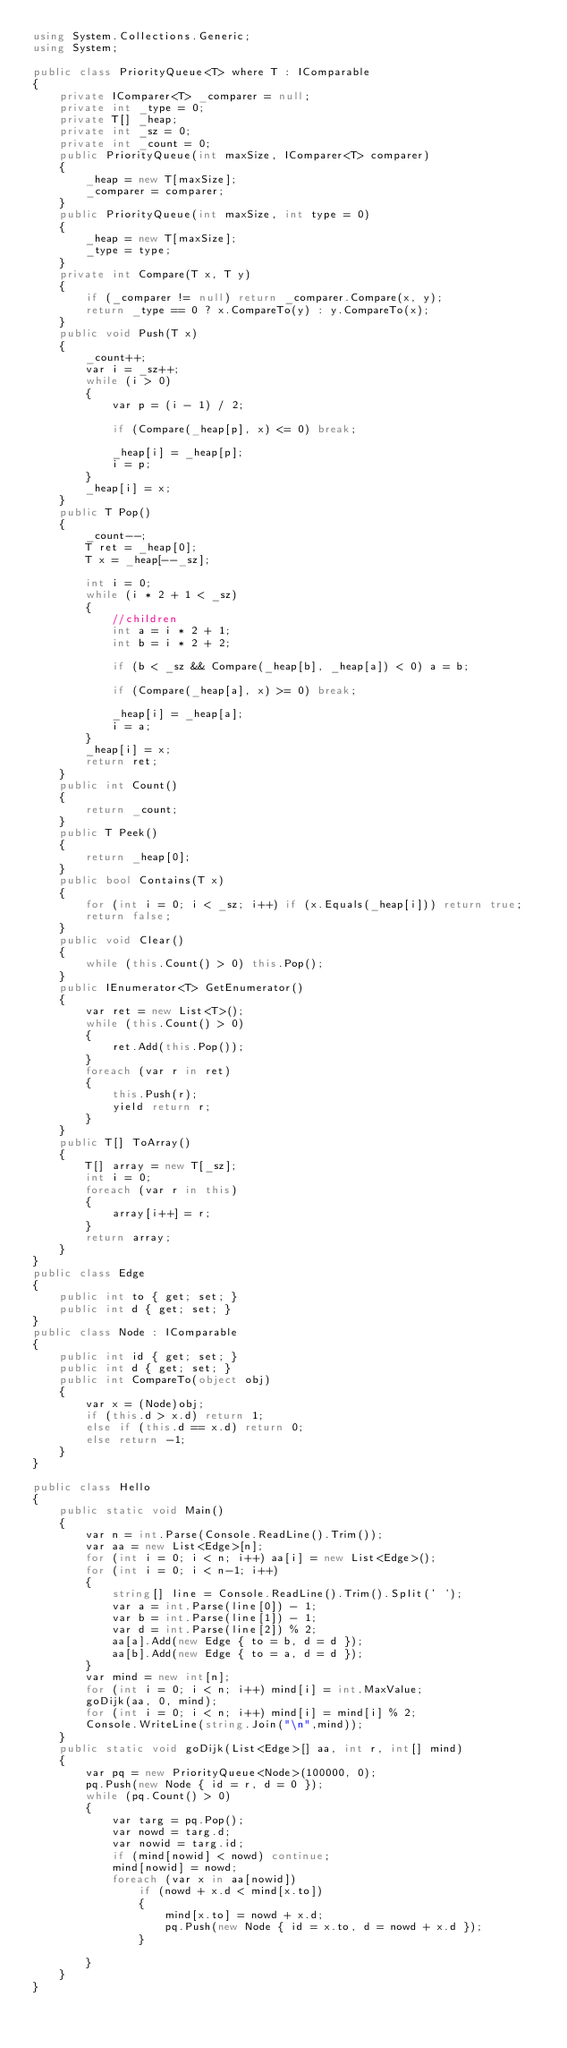Convert code to text. <code><loc_0><loc_0><loc_500><loc_500><_C#_>using System.Collections.Generic;
using System;

public class PriorityQueue<T> where T : IComparable
{
	private IComparer<T> _comparer = null;
	private int _type = 0;
	private T[] _heap;
	private int _sz = 0;
	private int _count = 0;
	public PriorityQueue(int maxSize, IComparer<T> comparer)
	{
		_heap = new T[maxSize];
		_comparer = comparer;
	}
	public PriorityQueue(int maxSize, int type = 0)
	{
		_heap = new T[maxSize];
		_type = type;
	}
	private int Compare(T x, T y)
	{
		if (_comparer != null) return _comparer.Compare(x, y);
		return _type == 0 ? x.CompareTo(y) : y.CompareTo(x);
	}
	public void Push(T x)
	{
		_count++;
		var i = _sz++;
		while (i > 0)
		{
			var p = (i - 1) / 2;

			if (Compare(_heap[p], x) <= 0) break;

			_heap[i] = _heap[p];
			i = p;
		}
		_heap[i] = x;
	}
	public T Pop()
	{
		_count--;
		T ret = _heap[0];
		T x = _heap[--_sz];

		int i = 0;
		while (i * 2 + 1 < _sz)
		{
			//children
			int a = i * 2 + 1;
			int b = i * 2 + 2;

			if (b < _sz && Compare(_heap[b], _heap[a]) < 0) a = b;

			if (Compare(_heap[a], x) >= 0) break;

			_heap[i] = _heap[a];
			i = a;
		}
		_heap[i] = x;
		return ret;
	}
	public int Count()
	{
		return _count;
	}
	public T Peek()
	{
		return _heap[0];
	}
	public bool Contains(T x)
	{
		for (int i = 0; i < _sz; i++) if (x.Equals(_heap[i])) return true;
		return false;
	}
	public void Clear()
	{
		while (this.Count() > 0) this.Pop();
	}
	public IEnumerator<T> GetEnumerator()
	{
		var ret = new List<T>();
		while (this.Count() > 0)
		{
			ret.Add(this.Pop());
		}
		foreach (var r in ret)
		{
			this.Push(r);
			yield return r;
		}
	}
	public T[] ToArray()
	{
		T[] array = new T[_sz];
		int i = 0;
		foreach (var r in this)
		{
			array[i++] = r;
		}
		return array;
	}
}
public class Edge
{
	public int to { get; set; }
	public int d { get; set; }
}
public class Node : IComparable
{
	public int id { get; set; }
	public int d { get; set; }
	public int CompareTo(object obj)
	{
		var x = (Node)obj;
		if (this.d > x.d) return 1;
		else if (this.d == x.d) return 0;
		else return -1;
	}
}

public class Hello
{
	public static void Main()
	{
		var n = int.Parse(Console.ReadLine().Trim());
		var aa = new List<Edge>[n];
		for (int i = 0; i < n; i++) aa[i] = new List<Edge>();
		for (int i = 0; i < n-1; i++)
		{
			string[] line = Console.ReadLine().Trim().Split(' ');
			var a = int.Parse(line[0]) - 1;
			var b = int.Parse(line[1]) - 1;
			var d = int.Parse(line[2]) % 2;
			aa[a].Add(new Edge { to = b, d = d });
			aa[b].Add(new Edge { to = a, d = d });
		}
		var mind = new int[n];
		for (int i = 0; i < n; i++) mind[i] = int.MaxValue;
		goDijk(aa, 0, mind);
		for (int i = 0; i < n; i++) mind[i] = mind[i] % 2;
		Console.WriteLine(string.Join("\n",mind));
	}
	public static void goDijk(List<Edge>[] aa, int r, int[] mind)
	{
		var pq = new PriorityQueue<Node>(100000, 0);
		pq.Push(new Node { id = r, d = 0 });
		while (pq.Count() > 0)
		{
			var targ = pq.Pop();
			var nowd = targ.d;
			var nowid = targ.id;
			if (mind[nowid] < nowd) continue;
			mind[nowid] = nowd;
			foreach (var x in aa[nowid])
				if (nowd + x.d < mind[x.to])
				{
					mind[x.to] = nowd + x.d;
					pq.Push(new Node { id = x.to, d = nowd + x.d });
				}

		}
	}
}</code> 